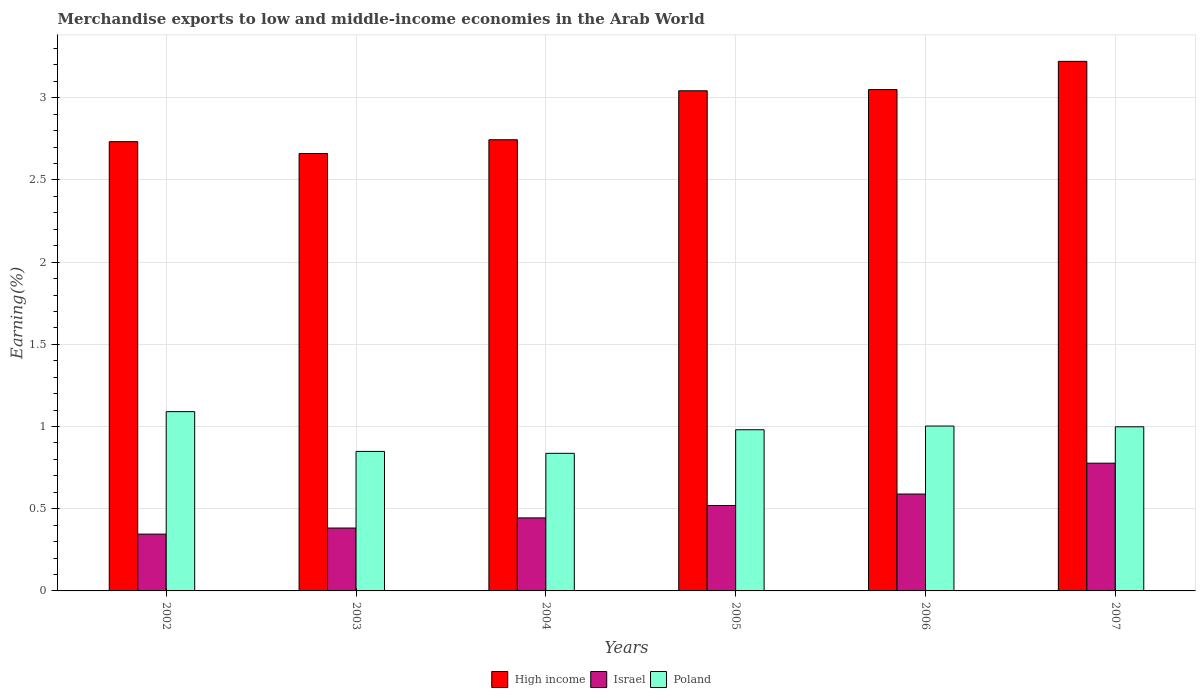How many different coloured bars are there?
Provide a succinct answer. 3. Are the number of bars on each tick of the X-axis equal?
Your response must be concise. Yes. How many bars are there on the 5th tick from the left?
Offer a terse response. 3. What is the label of the 4th group of bars from the left?
Your response must be concise. 2005. What is the percentage of amount earned from merchandise exports in Israel in 2005?
Make the answer very short. 0.52. Across all years, what is the maximum percentage of amount earned from merchandise exports in Israel?
Make the answer very short. 0.78. Across all years, what is the minimum percentage of amount earned from merchandise exports in Poland?
Provide a short and direct response. 0.84. In which year was the percentage of amount earned from merchandise exports in High income maximum?
Your answer should be very brief. 2007. In which year was the percentage of amount earned from merchandise exports in Poland minimum?
Keep it short and to the point. 2004. What is the total percentage of amount earned from merchandise exports in Israel in the graph?
Make the answer very short. 3.06. What is the difference between the percentage of amount earned from merchandise exports in Israel in 2002 and that in 2006?
Your answer should be compact. -0.24. What is the difference between the percentage of amount earned from merchandise exports in Poland in 2003 and the percentage of amount earned from merchandise exports in Israel in 2006?
Your response must be concise. 0.26. What is the average percentage of amount earned from merchandise exports in Israel per year?
Offer a very short reply. 0.51. In the year 2006, what is the difference between the percentage of amount earned from merchandise exports in Israel and percentage of amount earned from merchandise exports in Poland?
Keep it short and to the point. -0.41. In how many years, is the percentage of amount earned from merchandise exports in Poland greater than 2.6 %?
Ensure brevity in your answer.  0. What is the ratio of the percentage of amount earned from merchandise exports in Israel in 2004 to that in 2005?
Make the answer very short. 0.85. What is the difference between the highest and the second highest percentage of amount earned from merchandise exports in Poland?
Offer a terse response. 0.09. What is the difference between the highest and the lowest percentage of amount earned from merchandise exports in Poland?
Ensure brevity in your answer.  0.25. Is the sum of the percentage of amount earned from merchandise exports in Israel in 2003 and 2005 greater than the maximum percentage of amount earned from merchandise exports in High income across all years?
Offer a very short reply. No. What does the 3rd bar from the left in 2003 represents?
Provide a short and direct response. Poland. Is it the case that in every year, the sum of the percentage of amount earned from merchandise exports in Israel and percentage of amount earned from merchandise exports in High income is greater than the percentage of amount earned from merchandise exports in Poland?
Your answer should be very brief. Yes. Are all the bars in the graph horizontal?
Give a very brief answer. No. How many years are there in the graph?
Your answer should be very brief. 6. What is the difference between two consecutive major ticks on the Y-axis?
Provide a succinct answer. 0.5. Are the values on the major ticks of Y-axis written in scientific E-notation?
Keep it short and to the point. No. Does the graph contain any zero values?
Keep it short and to the point. No. Where does the legend appear in the graph?
Provide a succinct answer. Bottom center. How many legend labels are there?
Your response must be concise. 3. How are the legend labels stacked?
Provide a succinct answer. Horizontal. What is the title of the graph?
Provide a succinct answer. Merchandise exports to low and middle-income economies in the Arab World. Does "Japan" appear as one of the legend labels in the graph?
Your answer should be very brief. No. What is the label or title of the Y-axis?
Give a very brief answer. Earning(%). What is the Earning(%) of High income in 2002?
Provide a short and direct response. 2.73. What is the Earning(%) in Israel in 2002?
Give a very brief answer. 0.35. What is the Earning(%) in Poland in 2002?
Make the answer very short. 1.09. What is the Earning(%) of High income in 2003?
Offer a very short reply. 2.66. What is the Earning(%) of Israel in 2003?
Provide a succinct answer. 0.38. What is the Earning(%) of Poland in 2003?
Make the answer very short. 0.85. What is the Earning(%) in High income in 2004?
Provide a short and direct response. 2.74. What is the Earning(%) in Israel in 2004?
Offer a terse response. 0.44. What is the Earning(%) of Poland in 2004?
Give a very brief answer. 0.84. What is the Earning(%) in High income in 2005?
Offer a terse response. 3.04. What is the Earning(%) in Israel in 2005?
Offer a terse response. 0.52. What is the Earning(%) in Poland in 2005?
Your response must be concise. 0.98. What is the Earning(%) of High income in 2006?
Ensure brevity in your answer.  3.05. What is the Earning(%) in Israel in 2006?
Ensure brevity in your answer.  0.59. What is the Earning(%) of Poland in 2006?
Provide a succinct answer. 1. What is the Earning(%) of High income in 2007?
Offer a terse response. 3.22. What is the Earning(%) in Israel in 2007?
Your answer should be very brief. 0.78. What is the Earning(%) in Poland in 2007?
Offer a terse response. 1. Across all years, what is the maximum Earning(%) in High income?
Offer a very short reply. 3.22. Across all years, what is the maximum Earning(%) of Israel?
Keep it short and to the point. 0.78. Across all years, what is the maximum Earning(%) of Poland?
Your response must be concise. 1.09. Across all years, what is the minimum Earning(%) in High income?
Your response must be concise. 2.66. Across all years, what is the minimum Earning(%) of Israel?
Give a very brief answer. 0.35. Across all years, what is the minimum Earning(%) in Poland?
Keep it short and to the point. 0.84. What is the total Earning(%) of High income in the graph?
Keep it short and to the point. 17.45. What is the total Earning(%) in Israel in the graph?
Keep it short and to the point. 3.06. What is the total Earning(%) of Poland in the graph?
Your answer should be compact. 5.76. What is the difference between the Earning(%) in High income in 2002 and that in 2003?
Give a very brief answer. 0.07. What is the difference between the Earning(%) of Israel in 2002 and that in 2003?
Offer a terse response. -0.04. What is the difference between the Earning(%) in Poland in 2002 and that in 2003?
Provide a short and direct response. 0.24. What is the difference between the Earning(%) in High income in 2002 and that in 2004?
Provide a short and direct response. -0.01. What is the difference between the Earning(%) of Israel in 2002 and that in 2004?
Your response must be concise. -0.1. What is the difference between the Earning(%) in Poland in 2002 and that in 2004?
Make the answer very short. 0.25. What is the difference between the Earning(%) in High income in 2002 and that in 2005?
Make the answer very short. -0.31. What is the difference between the Earning(%) in Israel in 2002 and that in 2005?
Keep it short and to the point. -0.17. What is the difference between the Earning(%) of Poland in 2002 and that in 2005?
Offer a terse response. 0.11. What is the difference between the Earning(%) of High income in 2002 and that in 2006?
Keep it short and to the point. -0.32. What is the difference between the Earning(%) in Israel in 2002 and that in 2006?
Provide a short and direct response. -0.24. What is the difference between the Earning(%) in Poland in 2002 and that in 2006?
Offer a terse response. 0.09. What is the difference between the Earning(%) of High income in 2002 and that in 2007?
Ensure brevity in your answer.  -0.49. What is the difference between the Earning(%) in Israel in 2002 and that in 2007?
Ensure brevity in your answer.  -0.43. What is the difference between the Earning(%) of Poland in 2002 and that in 2007?
Make the answer very short. 0.09. What is the difference between the Earning(%) in High income in 2003 and that in 2004?
Offer a terse response. -0.08. What is the difference between the Earning(%) of Israel in 2003 and that in 2004?
Your response must be concise. -0.06. What is the difference between the Earning(%) of Poland in 2003 and that in 2004?
Offer a very short reply. 0.01. What is the difference between the Earning(%) of High income in 2003 and that in 2005?
Provide a succinct answer. -0.38. What is the difference between the Earning(%) of Israel in 2003 and that in 2005?
Offer a terse response. -0.14. What is the difference between the Earning(%) of Poland in 2003 and that in 2005?
Give a very brief answer. -0.13. What is the difference between the Earning(%) in High income in 2003 and that in 2006?
Provide a succinct answer. -0.39. What is the difference between the Earning(%) in Israel in 2003 and that in 2006?
Ensure brevity in your answer.  -0.21. What is the difference between the Earning(%) of Poland in 2003 and that in 2006?
Provide a succinct answer. -0.15. What is the difference between the Earning(%) of High income in 2003 and that in 2007?
Your answer should be compact. -0.56. What is the difference between the Earning(%) of Israel in 2003 and that in 2007?
Keep it short and to the point. -0.39. What is the difference between the Earning(%) in Poland in 2003 and that in 2007?
Ensure brevity in your answer.  -0.15. What is the difference between the Earning(%) in High income in 2004 and that in 2005?
Ensure brevity in your answer.  -0.3. What is the difference between the Earning(%) in Israel in 2004 and that in 2005?
Your answer should be very brief. -0.08. What is the difference between the Earning(%) of Poland in 2004 and that in 2005?
Make the answer very short. -0.14. What is the difference between the Earning(%) in High income in 2004 and that in 2006?
Keep it short and to the point. -0.31. What is the difference between the Earning(%) of Israel in 2004 and that in 2006?
Ensure brevity in your answer.  -0.15. What is the difference between the Earning(%) of Poland in 2004 and that in 2006?
Ensure brevity in your answer.  -0.17. What is the difference between the Earning(%) in High income in 2004 and that in 2007?
Ensure brevity in your answer.  -0.48. What is the difference between the Earning(%) in Israel in 2004 and that in 2007?
Give a very brief answer. -0.33. What is the difference between the Earning(%) in Poland in 2004 and that in 2007?
Offer a very short reply. -0.16. What is the difference between the Earning(%) in High income in 2005 and that in 2006?
Give a very brief answer. -0.01. What is the difference between the Earning(%) of Israel in 2005 and that in 2006?
Make the answer very short. -0.07. What is the difference between the Earning(%) in Poland in 2005 and that in 2006?
Offer a very short reply. -0.02. What is the difference between the Earning(%) of High income in 2005 and that in 2007?
Give a very brief answer. -0.18. What is the difference between the Earning(%) in Israel in 2005 and that in 2007?
Provide a short and direct response. -0.26. What is the difference between the Earning(%) of Poland in 2005 and that in 2007?
Keep it short and to the point. -0.02. What is the difference between the Earning(%) of High income in 2006 and that in 2007?
Provide a short and direct response. -0.17. What is the difference between the Earning(%) in Israel in 2006 and that in 2007?
Keep it short and to the point. -0.19. What is the difference between the Earning(%) in Poland in 2006 and that in 2007?
Your answer should be compact. 0. What is the difference between the Earning(%) in High income in 2002 and the Earning(%) in Israel in 2003?
Offer a terse response. 2.35. What is the difference between the Earning(%) in High income in 2002 and the Earning(%) in Poland in 2003?
Your answer should be very brief. 1.88. What is the difference between the Earning(%) of Israel in 2002 and the Earning(%) of Poland in 2003?
Your response must be concise. -0.5. What is the difference between the Earning(%) of High income in 2002 and the Earning(%) of Israel in 2004?
Provide a succinct answer. 2.29. What is the difference between the Earning(%) in High income in 2002 and the Earning(%) in Poland in 2004?
Make the answer very short. 1.9. What is the difference between the Earning(%) in Israel in 2002 and the Earning(%) in Poland in 2004?
Offer a terse response. -0.49. What is the difference between the Earning(%) in High income in 2002 and the Earning(%) in Israel in 2005?
Offer a very short reply. 2.21. What is the difference between the Earning(%) of High income in 2002 and the Earning(%) of Poland in 2005?
Your response must be concise. 1.75. What is the difference between the Earning(%) of Israel in 2002 and the Earning(%) of Poland in 2005?
Keep it short and to the point. -0.63. What is the difference between the Earning(%) in High income in 2002 and the Earning(%) in Israel in 2006?
Ensure brevity in your answer.  2.14. What is the difference between the Earning(%) in High income in 2002 and the Earning(%) in Poland in 2006?
Your answer should be very brief. 1.73. What is the difference between the Earning(%) of Israel in 2002 and the Earning(%) of Poland in 2006?
Make the answer very short. -0.66. What is the difference between the Earning(%) in High income in 2002 and the Earning(%) in Israel in 2007?
Your response must be concise. 1.96. What is the difference between the Earning(%) of High income in 2002 and the Earning(%) of Poland in 2007?
Give a very brief answer. 1.73. What is the difference between the Earning(%) of Israel in 2002 and the Earning(%) of Poland in 2007?
Your answer should be very brief. -0.65. What is the difference between the Earning(%) of High income in 2003 and the Earning(%) of Israel in 2004?
Your response must be concise. 2.22. What is the difference between the Earning(%) in High income in 2003 and the Earning(%) in Poland in 2004?
Your answer should be compact. 1.82. What is the difference between the Earning(%) in Israel in 2003 and the Earning(%) in Poland in 2004?
Make the answer very short. -0.45. What is the difference between the Earning(%) in High income in 2003 and the Earning(%) in Israel in 2005?
Your response must be concise. 2.14. What is the difference between the Earning(%) in High income in 2003 and the Earning(%) in Poland in 2005?
Offer a very short reply. 1.68. What is the difference between the Earning(%) of Israel in 2003 and the Earning(%) of Poland in 2005?
Give a very brief answer. -0.6. What is the difference between the Earning(%) of High income in 2003 and the Earning(%) of Israel in 2006?
Offer a terse response. 2.07. What is the difference between the Earning(%) in High income in 2003 and the Earning(%) in Poland in 2006?
Offer a terse response. 1.66. What is the difference between the Earning(%) in Israel in 2003 and the Earning(%) in Poland in 2006?
Offer a terse response. -0.62. What is the difference between the Earning(%) in High income in 2003 and the Earning(%) in Israel in 2007?
Keep it short and to the point. 1.88. What is the difference between the Earning(%) in High income in 2003 and the Earning(%) in Poland in 2007?
Your answer should be compact. 1.66. What is the difference between the Earning(%) of Israel in 2003 and the Earning(%) of Poland in 2007?
Give a very brief answer. -0.62. What is the difference between the Earning(%) in High income in 2004 and the Earning(%) in Israel in 2005?
Your answer should be compact. 2.23. What is the difference between the Earning(%) of High income in 2004 and the Earning(%) of Poland in 2005?
Your response must be concise. 1.76. What is the difference between the Earning(%) in Israel in 2004 and the Earning(%) in Poland in 2005?
Give a very brief answer. -0.54. What is the difference between the Earning(%) in High income in 2004 and the Earning(%) in Israel in 2006?
Offer a very short reply. 2.16. What is the difference between the Earning(%) of High income in 2004 and the Earning(%) of Poland in 2006?
Give a very brief answer. 1.74. What is the difference between the Earning(%) in Israel in 2004 and the Earning(%) in Poland in 2006?
Provide a succinct answer. -0.56. What is the difference between the Earning(%) in High income in 2004 and the Earning(%) in Israel in 2007?
Offer a terse response. 1.97. What is the difference between the Earning(%) in High income in 2004 and the Earning(%) in Poland in 2007?
Make the answer very short. 1.75. What is the difference between the Earning(%) in Israel in 2004 and the Earning(%) in Poland in 2007?
Ensure brevity in your answer.  -0.55. What is the difference between the Earning(%) of High income in 2005 and the Earning(%) of Israel in 2006?
Your response must be concise. 2.45. What is the difference between the Earning(%) of High income in 2005 and the Earning(%) of Poland in 2006?
Provide a short and direct response. 2.04. What is the difference between the Earning(%) in Israel in 2005 and the Earning(%) in Poland in 2006?
Keep it short and to the point. -0.48. What is the difference between the Earning(%) in High income in 2005 and the Earning(%) in Israel in 2007?
Make the answer very short. 2.27. What is the difference between the Earning(%) of High income in 2005 and the Earning(%) of Poland in 2007?
Provide a succinct answer. 2.04. What is the difference between the Earning(%) in Israel in 2005 and the Earning(%) in Poland in 2007?
Offer a terse response. -0.48. What is the difference between the Earning(%) in High income in 2006 and the Earning(%) in Israel in 2007?
Make the answer very short. 2.27. What is the difference between the Earning(%) in High income in 2006 and the Earning(%) in Poland in 2007?
Ensure brevity in your answer.  2.05. What is the difference between the Earning(%) of Israel in 2006 and the Earning(%) of Poland in 2007?
Give a very brief answer. -0.41. What is the average Earning(%) of High income per year?
Your response must be concise. 2.91. What is the average Earning(%) of Israel per year?
Give a very brief answer. 0.51. What is the average Earning(%) in Poland per year?
Your response must be concise. 0.96. In the year 2002, what is the difference between the Earning(%) of High income and Earning(%) of Israel?
Offer a very short reply. 2.39. In the year 2002, what is the difference between the Earning(%) in High income and Earning(%) in Poland?
Provide a succinct answer. 1.64. In the year 2002, what is the difference between the Earning(%) of Israel and Earning(%) of Poland?
Your response must be concise. -0.74. In the year 2003, what is the difference between the Earning(%) in High income and Earning(%) in Israel?
Provide a succinct answer. 2.28. In the year 2003, what is the difference between the Earning(%) in High income and Earning(%) in Poland?
Keep it short and to the point. 1.81. In the year 2003, what is the difference between the Earning(%) in Israel and Earning(%) in Poland?
Give a very brief answer. -0.47. In the year 2004, what is the difference between the Earning(%) in High income and Earning(%) in Israel?
Your answer should be compact. 2.3. In the year 2004, what is the difference between the Earning(%) of High income and Earning(%) of Poland?
Your answer should be very brief. 1.91. In the year 2004, what is the difference between the Earning(%) of Israel and Earning(%) of Poland?
Offer a terse response. -0.39. In the year 2005, what is the difference between the Earning(%) of High income and Earning(%) of Israel?
Provide a succinct answer. 2.52. In the year 2005, what is the difference between the Earning(%) of High income and Earning(%) of Poland?
Keep it short and to the point. 2.06. In the year 2005, what is the difference between the Earning(%) of Israel and Earning(%) of Poland?
Provide a short and direct response. -0.46. In the year 2006, what is the difference between the Earning(%) of High income and Earning(%) of Israel?
Offer a terse response. 2.46. In the year 2006, what is the difference between the Earning(%) of High income and Earning(%) of Poland?
Keep it short and to the point. 2.05. In the year 2006, what is the difference between the Earning(%) in Israel and Earning(%) in Poland?
Give a very brief answer. -0.41. In the year 2007, what is the difference between the Earning(%) in High income and Earning(%) in Israel?
Keep it short and to the point. 2.44. In the year 2007, what is the difference between the Earning(%) in High income and Earning(%) in Poland?
Offer a very short reply. 2.22. In the year 2007, what is the difference between the Earning(%) of Israel and Earning(%) of Poland?
Give a very brief answer. -0.22. What is the ratio of the Earning(%) of High income in 2002 to that in 2003?
Keep it short and to the point. 1.03. What is the ratio of the Earning(%) of Israel in 2002 to that in 2003?
Offer a terse response. 0.9. What is the ratio of the Earning(%) of Poland in 2002 to that in 2003?
Ensure brevity in your answer.  1.28. What is the ratio of the Earning(%) in High income in 2002 to that in 2004?
Your answer should be very brief. 1. What is the ratio of the Earning(%) in Israel in 2002 to that in 2004?
Make the answer very short. 0.78. What is the ratio of the Earning(%) of Poland in 2002 to that in 2004?
Your response must be concise. 1.3. What is the ratio of the Earning(%) of High income in 2002 to that in 2005?
Your answer should be compact. 0.9. What is the ratio of the Earning(%) of Israel in 2002 to that in 2005?
Ensure brevity in your answer.  0.67. What is the ratio of the Earning(%) of Poland in 2002 to that in 2005?
Make the answer very short. 1.11. What is the ratio of the Earning(%) in High income in 2002 to that in 2006?
Offer a very short reply. 0.9. What is the ratio of the Earning(%) of Israel in 2002 to that in 2006?
Make the answer very short. 0.59. What is the ratio of the Earning(%) in Poland in 2002 to that in 2006?
Provide a short and direct response. 1.09. What is the ratio of the Earning(%) of High income in 2002 to that in 2007?
Provide a short and direct response. 0.85. What is the ratio of the Earning(%) of Israel in 2002 to that in 2007?
Your response must be concise. 0.44. What is the ratio of the Earning(%) of Poland in 2002 to that in 2007?
Keep it short and to the point. 1.09. What is the ratio of the Earning(%) in High income in 2003 to that in 2004?
Offer a very short reply. 0.97. What is the ratio of the Earning(%) of Israel in 2003 to that in 2004?
Your answer should be very brief. 0.86. What is the ratio of the Earning(%) in Poland in 2003 to that in 2004?
Your answer should be compact. 1.01. What is the ratio of the Earning(%) of High income in 2003 to that in 2005?
Your answer should be compact. 0.87. What is the ratio of the Earning(%) of Israel in 2003 to that in 2005?
Make the answer very short. 0.74. What is the ratio of the Earning(%) in Poland in 2003 to that in 2005?
Your answer should be very brief. 0.87. What is the ratio of the Earning(%) in High income in 2003 to that in 2006?
Your answer should be compact. 0.87. What is the ratio of the Earning(%) in Israel in 2003 to that in 2006?
Your answer should be compact. 0.65. What is the ratio of the Earning(%) in Poland in 2003 to that in 2006?
Offer a very short reply. 0.85. What is the ratio of the Earning(%) in High income in 2003 to that in 2007?
Offer a very short reply. 0.83. What is the ratio of the Earning(%) in Israel in 2003 to that in 2007?
Offer a very short reply. 0.49. What is the ratio of the Earning(%) of Poland in 2003 to that in 2007?
Make the answer very short. 0.85. What is the ratio of the Earning(%) in High income in 2004 to that in 2005?
Your response must be concise. 0.9. What is the ratio of the Earning(%) in Israel in 2004 to that in 2005?
Your response must be concise. 0.85. What is the ratio of the Earning(%) of Poland in 2004 to that in 2005?
Provide a succinct answer. 0.85. What is the ratio of the Earning(%) in High income in 2004 to that in 2006?
Offer a terse response. 0.9. What is the ratio of the Earning(%) of Israel in 2004 to that in 2006?
Ensure brevity in your answer.  0.75. What is the ratio of the Earning(%) in Poland in 2004 to that in 2006?
Make the answer very short. 0.83. What is the ratio of the Earning(%) in High income in 2004 to that in 2007?
Your answer should be compact. 0.85. What is the ratio of the Earning(%) of Israel in 2004 to that in 2007?
Offer a very short reply. 0.57. What is the ratio of the Earning(%) of Poland in 2004 to that in 2007?
Give a very brief answer. 0.84. What is the ratio of the Earning(%) in Israel in 2005 to that in 2006?
Your response must be concise. 0.88. What is the ratio of the Earning(%) of Poland in 2005 to that in 2006?
Provide a short and direct response. 0.98. What is the ratio of the Earning(%) in High income in 2005 to that in 2007?
Your response must be concise. 0.94. What is the ratio of the Earning(%) in Israel in 2005 to that in 2007?
Make the answer very short. 0.67. What is the ratio of the Earning(%) in Poland in 2005 to that in 2007?
Ensure brevity in your answer.  0.98. What is the ratio of the Earning(%) in High income in 2006 to that in 2007?
Offer a very short reply. 0.95. What is the ratio of the Earning(%) of Israel in 2006 to that in 2007?
Give a very brief answer. 0.76. What is the difference between the highest and the second highest Earning(%) of High income?
Offer a terse response. 0.17. What is the difference between the highest and the second highest Earning(%) of Israel?
Offer a terse response. 0.19. What is the difference between the highest and the second highest Earning(%) of Poland?
Your answer should be compact. 0.09. What is the difference between the highest and the lowest Earning(%) in High income?
Ensure brevity in your answer.  0.56. What is the difference between the highest and the lowest Earning(%) of Israel?
Ensure brevity in your answer.  0.43. What is the difference between the highest and the lowest Earning(%) in Poland?
Offer a very short reply. 0.25. 